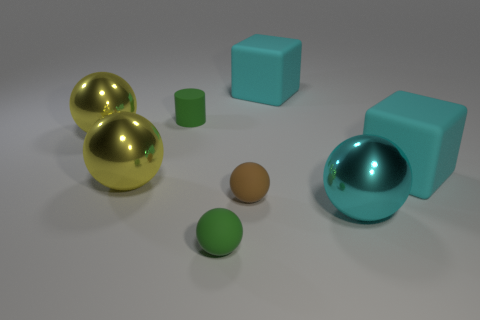Imagine these objects are part of a larger scene; what could it be? These objects could be part of a minimalist art installation that plays with geometry, color contrast, and reflections to engage viewers in a visual exploration of shape and space. 